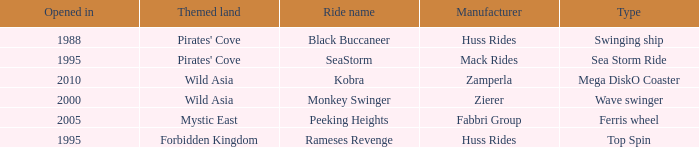Which ride opened after the 2000 Peeking Heights? Ferris wheel. 